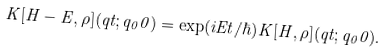Convert formula to latex. <formula><loc_0><loc_0><loc_500><loc_500>K [ H - E , \rho ] ( q t ; q _ { 0 } 0 ) = \exp ( i E t / \hbar { ) } K [ H , \rho ] ( q t ; q _ { 0 } 0 ) .</formula> 